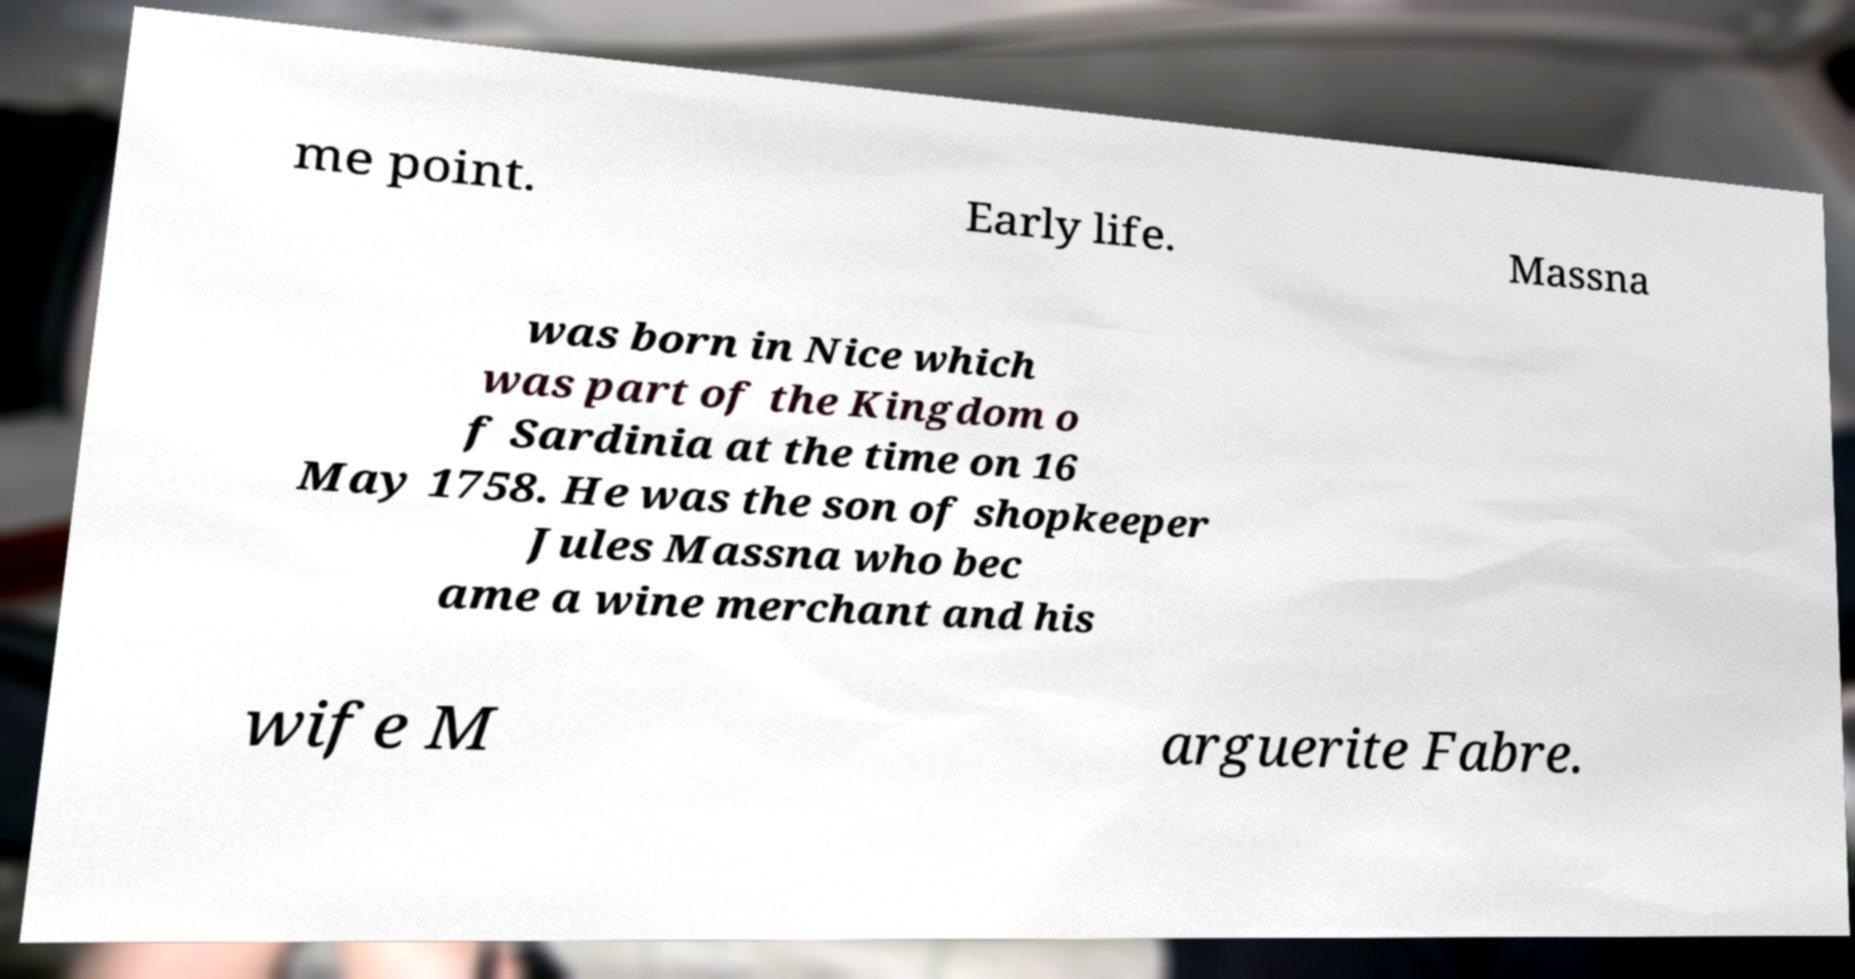What messages or text are displayed in this image? I need them in a readable, typed format. me point. Early life. Massna was born in Nice which was part of the Kingdom o f Sardinia at the time on 16 May 1758. He was the son of shopkeeper Jules Massna who bec ame a wine merchant and his wife M arguerite Fabre. 